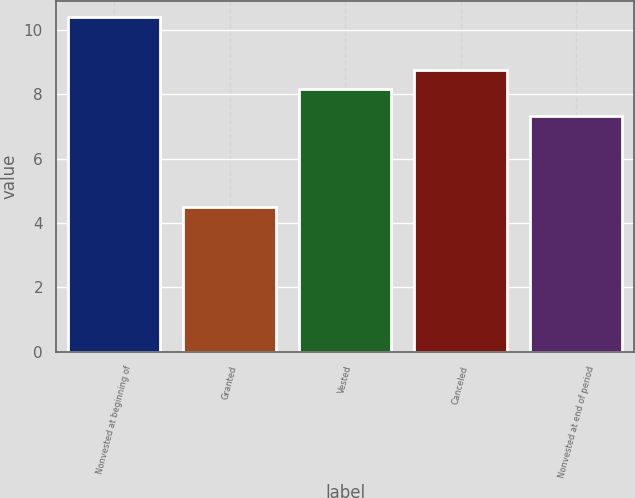<chart> <loc_0><loc_0><loc_500><loc_500><bar_chart><fcel>Nonvested at beginning of<fcel>Granted<fcel>Vested<fcel>Canceled<fcel>Nonvested at end of period<nl><fcel>10.39<fcel>4.48<fcel>8.16<fcel>8.75<fcel>7.32<nl></chart> 